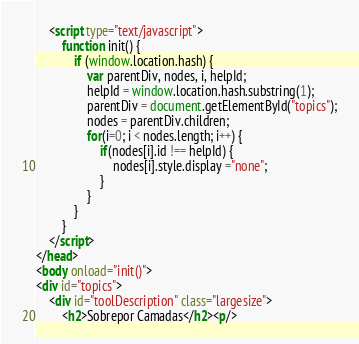Convert code to text. <code><loc_0><loc_0><loc_500><loc_500><_HTML_>    <script type="text/javascript">
        function init() {
            if (window.location.hash) {
                var parentDiv, nodes, i, helpId;
                helpId = window.location.hash.substring(1);
                parentDiv = document.getElementById("topics");
                nodes = parentDiv.children;
                for(i=0; i < nodes.length; i++) {
                    if(nodes[i].id !== helpId) {
                        nodes[i].style.display ="none";
                    }
                }
            }
        }
    </script>
</head>
<body onload="init()">
<div id="topics">
    <div id="toolDescription" class="largesize">
        <h2>Sobrepor Camadas</h2><p/></code> 